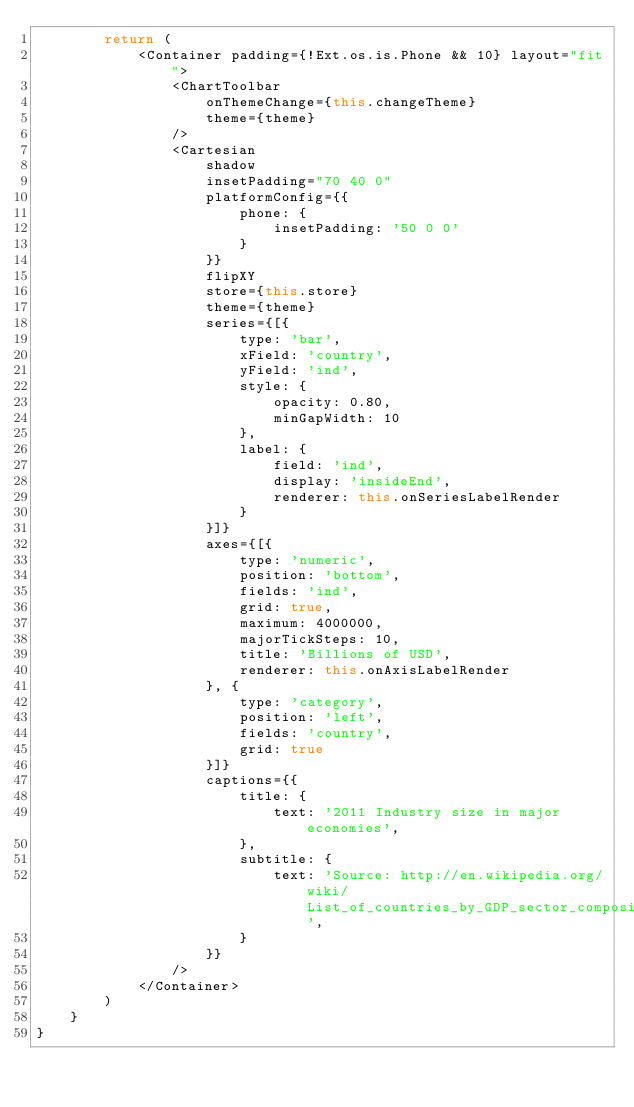Convert code to text. <code><loc_0><loc_0><loc_500><loc_500><_JavaScript_>        return (
            <Container padding={!Ext.os.is.Phone && 10} layout="fit">
                <ChartToolbar
                    onThemeChange={this.changeTheme}
                    theme={theme}
                />
                <Cartesian
                    shadow
                    insetPadding="70 40 0"
                    platformConfig={{
                        phone: {
                            insetPadding: '50 0 0'
                        }
                    }}
                    flipXY
                    store={this.store}
                    theme={theme}
                    series={[{
                        type: 'bar',
                        xField: 'country',
                        yField: 'ind',
                        style: {
                            opacity: 0.80,
                            minGapWidth: 10
                        },
                        label: {
                            field: 'ind',
                            display: 'insideEnd',
                            renderer: this.onSeriesLabelRender
                        }
                    }]}
                    axes={[{
                        type: 'numeric',
                        position: 'bottom',
                        fields: 'ind',
                        grid: true,
                        maximum: 4000000,
                        majorTickSteps: 10,
                        title: 'Billions of USD',
                        renderer: this.onAxisLabelRender
                    }, {
                        type: 'category',
                        position: 'left',
                        fields: 'country',
                        grid: true
                    }]}
                    captions={{
                        title: {
                            text: '2011 Industry size in major economies',
                        },
                        subtitle: {
                            text: 'Source: http://en.wikipedia.org/wiki/List_of_countries_by_GDP_sector_composition',
                        }
                    }}
                />
            </Container>            
        )
    }
}</code> 